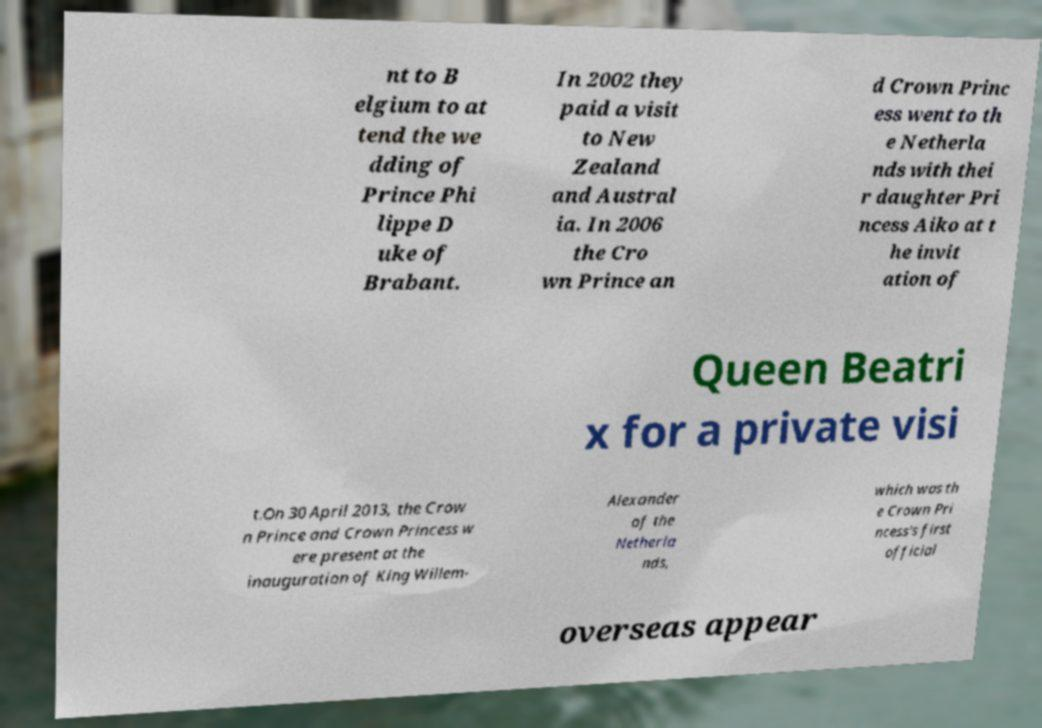What messages or text are displayed in this image? I need them in a readable, typed format. nt to B elgium to at tend the we dding of Prince Phi lippe D uke of Brabant. In 2002 they paid a visit to New Zealand and Austral ia. In 2006 the Cro wn Prince an d Crown Princ ess went to th e Netherla nds with thei r daughter Pri ncess Aiko at t he invit ation of Queen Beatri x for a private visi t.On 30 April 2013, the Crow n Prince and Crown Princess w ere present at the inauguration of King Willem- Alexander of the Netherla nds, which was th e Crown Pri ncess's first official overseas appear 